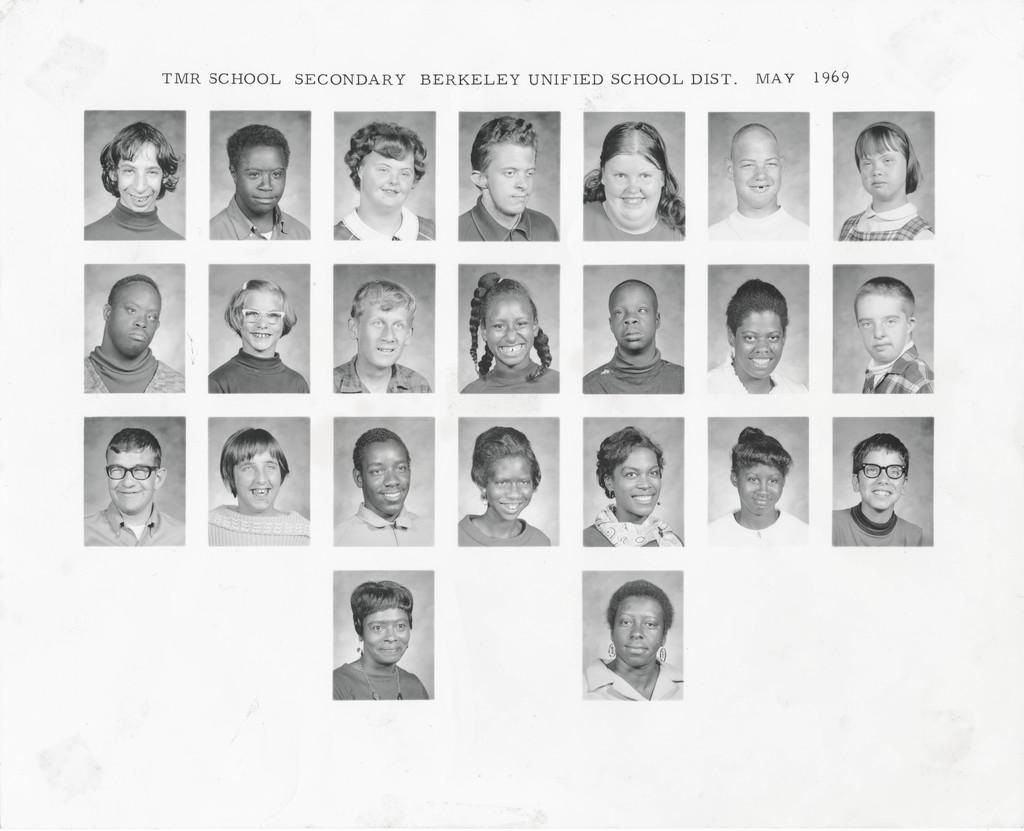What is the color scheme of the image? The image is black and white. What can be seen in the photographs within the image? There are photographs of a group of people in the image. How are some of the people in the photographs depicted? Some of the people in the photographs are smiling. What is written at the top of the image? There is text at the top of the image. What type of chalk is being used by the achiever in the image? There is no chalk or achiever present in the image. How much waste is visible in the image? There is no waste visible in the image; it is a black and white image with photographs of a group of people. 